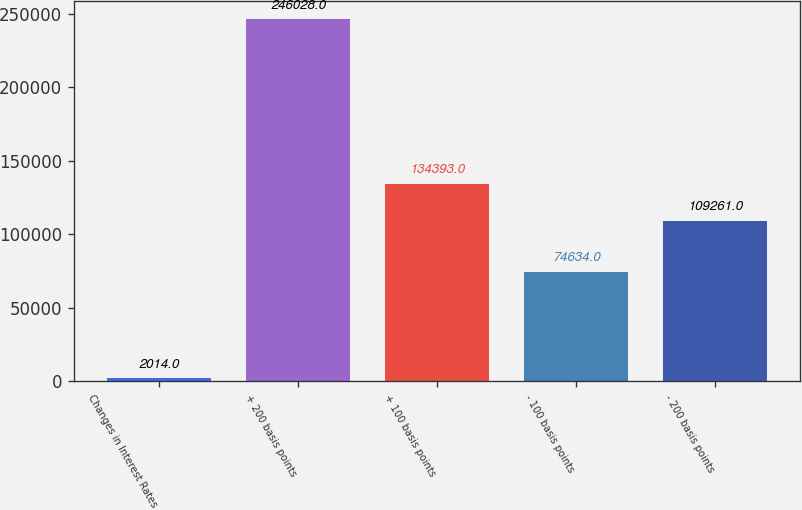Convert chart. <chart><loc_0><loc_0><loc_500><loc_500><bar_chart><fcel>Changes in Interest Rates<fcel>+ 200 basis points<fcel>+ 100 basis points<fcel>- 100 basis points<fcel>- 200 basis points<nl><fcel>2014<fcel>246028<fcel>134393<fcel>74634<fcel>109261<nl></chart> 